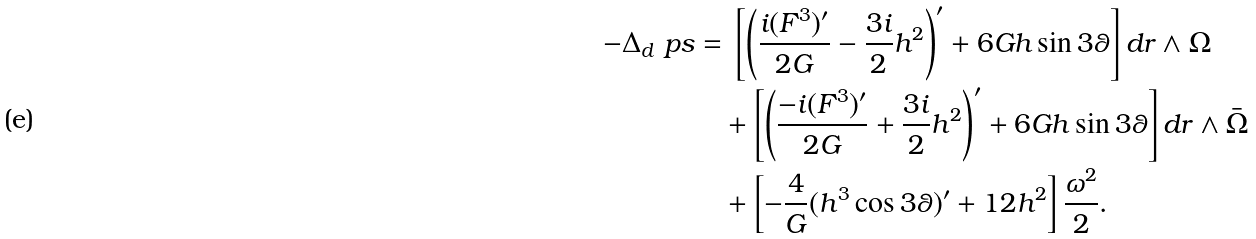<formula> <loc_0><loc_0><loc_500><loc_500>- \Delta _ { d } \ p s & = \, \left [ \left ( \frac { i ( F ^ { 3 } ) ^ { \prime } } { 2 G } - \frac { 3 i } { 2 } h ^ { 2 } \right ) ^ { \prime } + 6 G h \sin 3 \theta \right ] d r \wedge \Omega \\ & \quad + \left [ \left ( \frac { - i ( F ^ { 3 } ) ^ { \prime } } { 2 G } + \frac { 3 i } { 2 } h ^ { 2 } \right ) ^ { \prime } + 6 G h \sin 3 \theta \right ] d r \wedge \bar { \Omega } \\ & \quad + \left [ - \frac { 4 } { G } ( h ^ { 3 } \cos 3 \theta ) ^ { \prime } + 1 2 h ^ { 2 } \right ] \frac { \omega ^ { 2 } } { 2 } .</formula> 